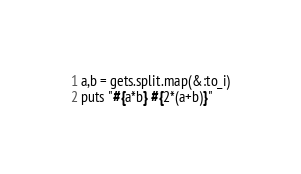Convert code to text. <code><loc_0><loc_0><loc_500><loc_500><_Ruby_>a,b = gets.split.map(&:to_i)
puts "#{a*b} #{2*(a+b)}"</code> 